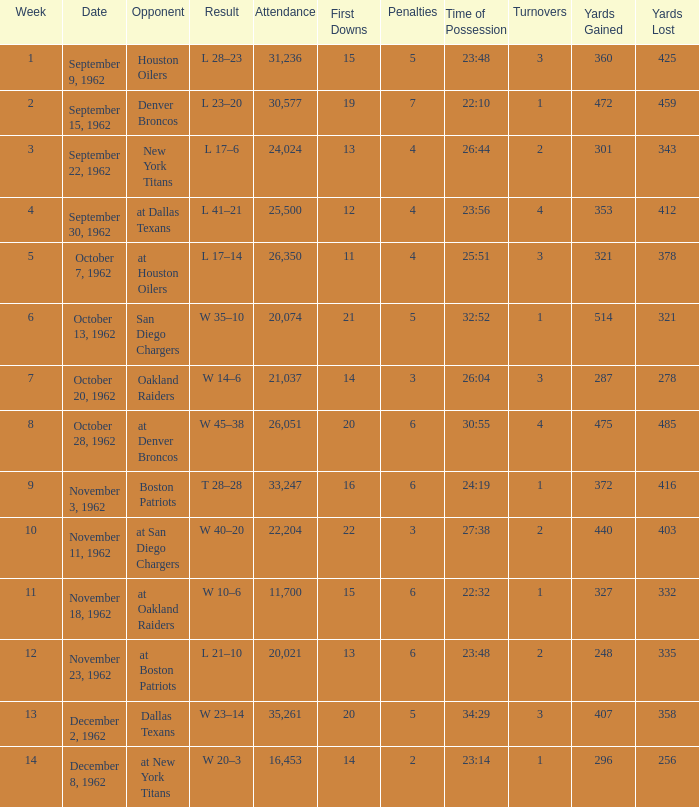What week was the attendance smaller than 22,204 on December 8, 1962? 14.0. 